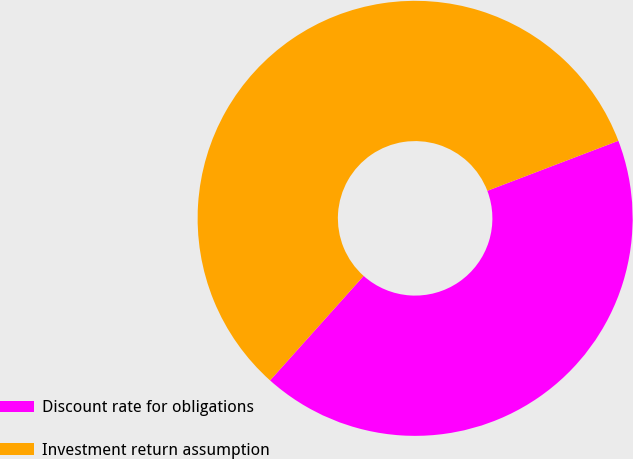Convert chart to OTSL. <chart><loc_0><loc_0><loc_500><loc_500><pie_chart><fcel>Discount rate for obligations<fcel>Investment return assumption<nl><fcel>42.42%<fcel>57.58%<nl></chart> 